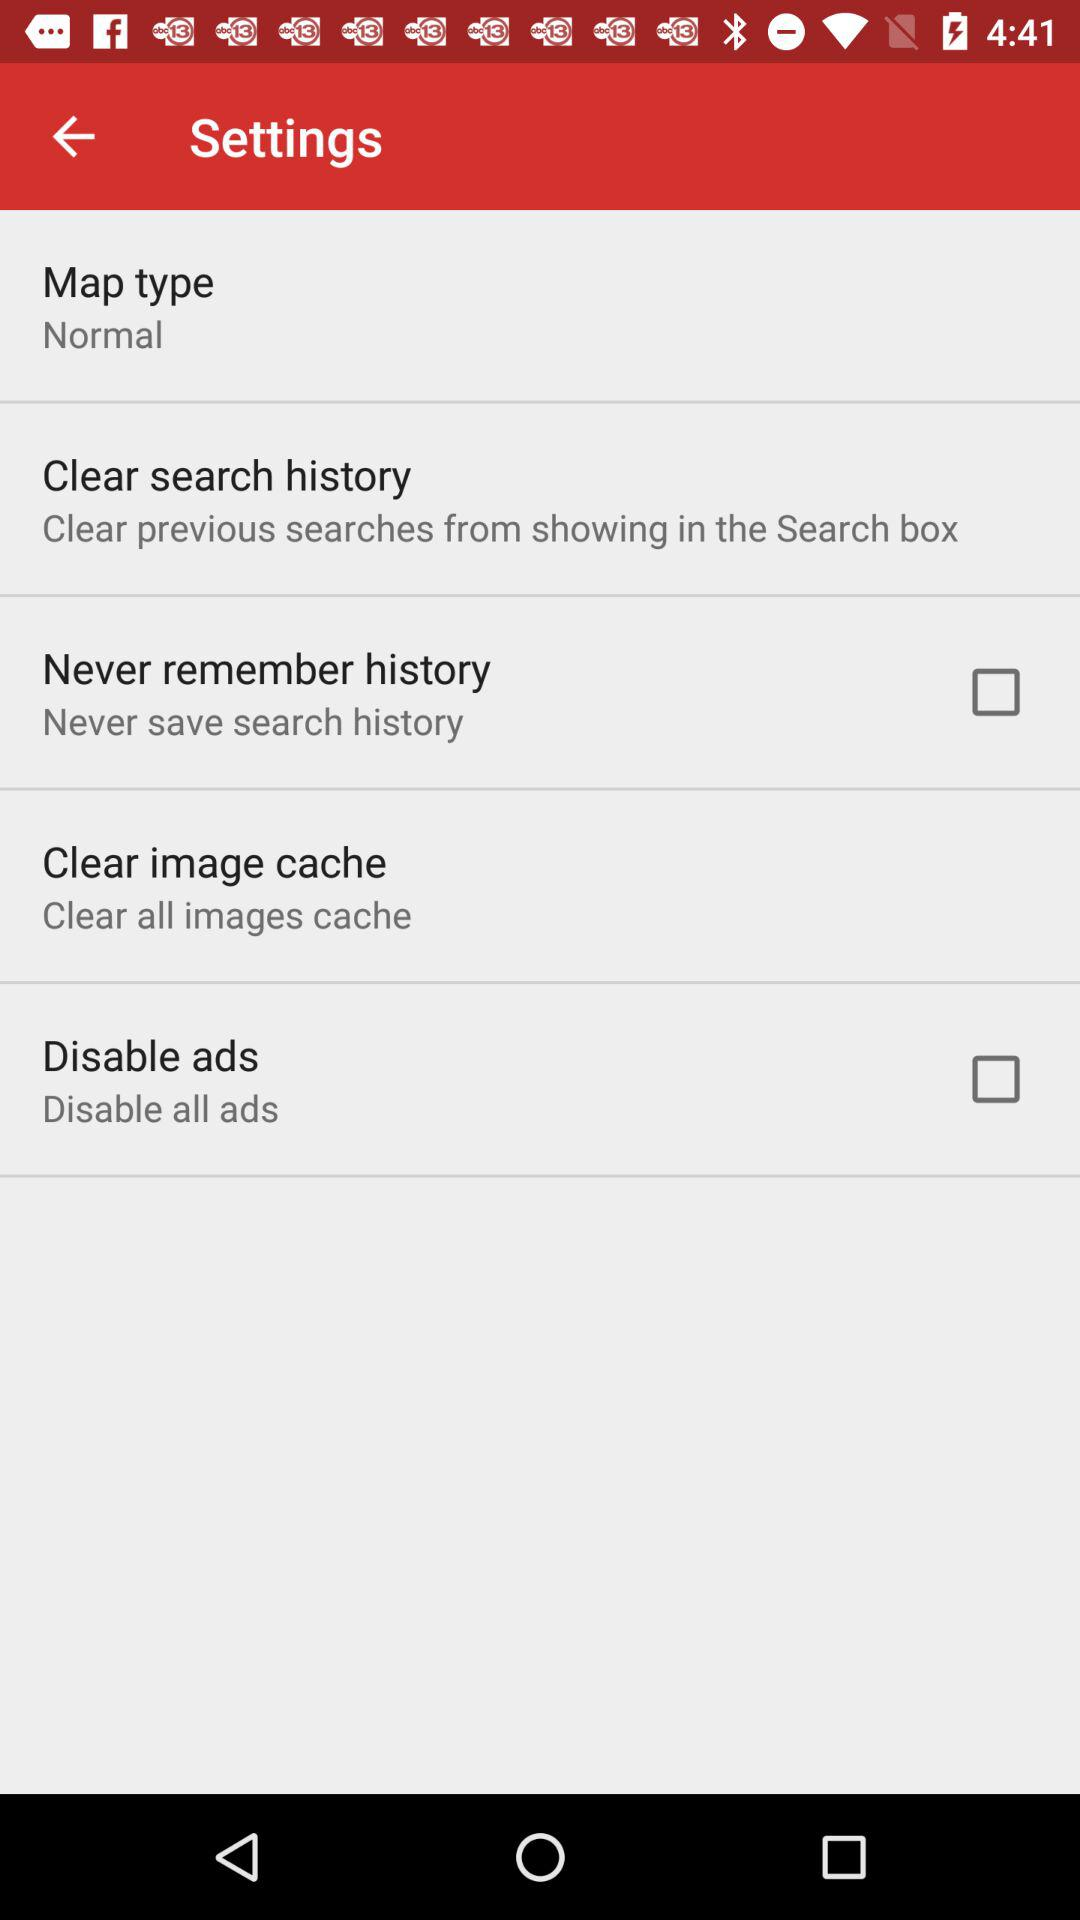What is the current status of the "Disable ads"? The current status is "off". 